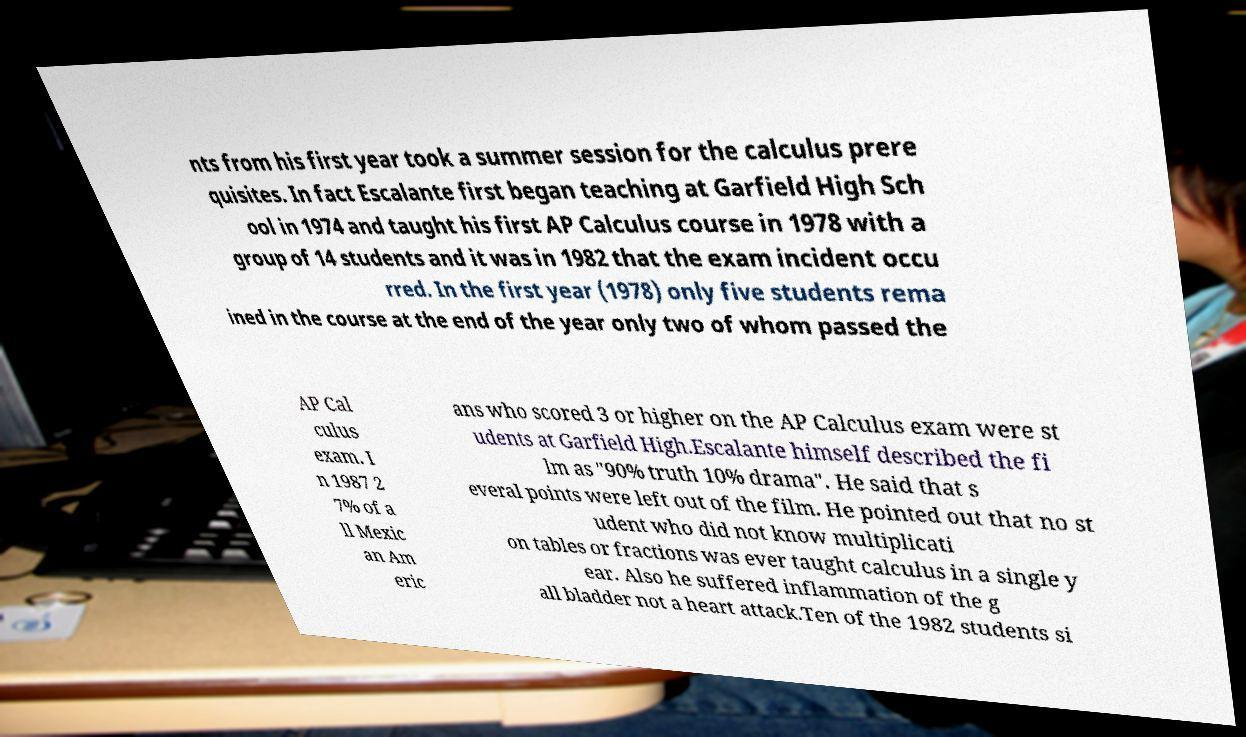Please identify and transcribe the text found in this image. nts from his first year took a summer session for the calculus prere quisites. In fact Escalante first began teaching at Garfield High Sch ool in 1974 and taught his first AP Calculus course in 1978 with a group of 14 students and it was in 1982 that the exam incident occu rred. In the first year (1978) only five students rema ined in the course at the end of the year only two of whom passed the AP Cal culus exam. I n 1987 2 7% of a ll Mexic an Am eric ans who scored 3 or higher on the AP Calculus exam were st udents at Garfield High.Escalante himself described the fi lm as "90% truth 10% drama". He said that s everal points were left out of the film. He pointed out that no st udent who did not know multiplicati on tables or fractions was ever taught calculus in a single y ear. Also he suffered inflammation of the g all bladder not a heart attack.Ten of the 1982 students si 